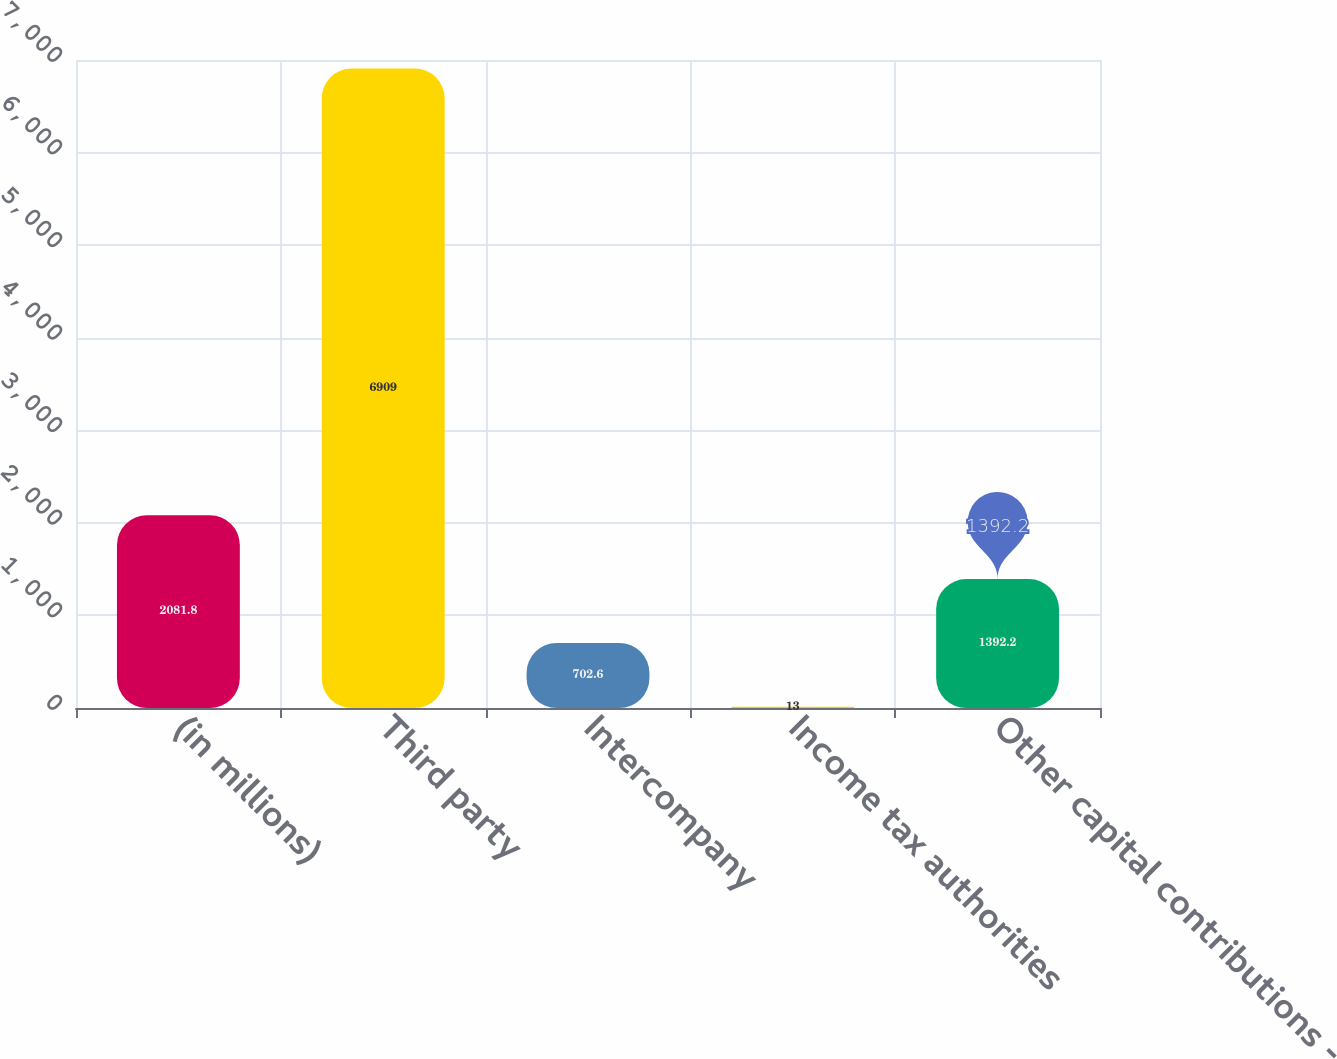<chart> <loc_0><loc_0><loc_500><loc_500><bar_chart><fcel>(in millions)<fcel>Third party<fcel>Intercompany<fcel>Income tax authorities<fcel>Other capital contributions -<nl><fcel>2081.8<fcel>6909<fcel>702.6<fcel>13<fcel>1392.2<nl></chart> 